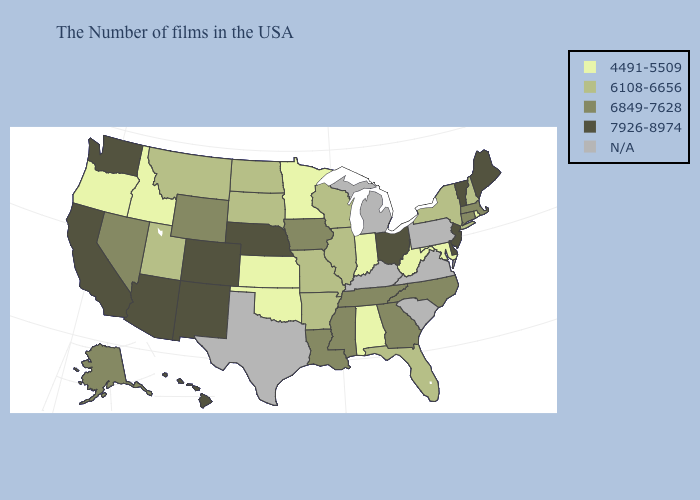Name the states that have a value in the range 4491-5509?
Concise answer only. Rhode Island, Maryland, West Virginia, Indiana, Alabama, Minnesota, Kansas, Oklahoma, Idaho, Oregon. Among the states that border Alabama , does Georgia have the lowest value?
Give a very brief answer. No. Name the states that have a value in the range 7926-8974?
Write a very short answer. Maine, Vermont, New Jersey, Delaware, Ohio, Nebraska, Colorado, New Mexico, Arizona, California, Washington, Hawaii. What is the value of Oklahoma?
Be succinct. 4491-5509. Name the states that have a value in the range 7926-8974?
Quick response, please. Maine, Vermont, New Jersey, Delaware, Ohio, Nebraska, Colorado, New Mexico, Arizona, California, Washington, Hawaii. What is the value of Delaware?
Keep it brief. 7926-8974. What is the value of Montana?
Give a very brief answer. 6108-6656. Does the map have missing data?
Short answer required. Yes. What is the value of Pennsylvania?
Short answer required. N/A. What is the value of Utah?
Quick response, please. 6108-6656. What is the highest value in the MidWest ?
Answer briefly. 7926-8974. How many symbols are there in the legend?
Give a very brief answer. 5. Does Maryland have the highest value in the USA?
Keep it brief. No. 